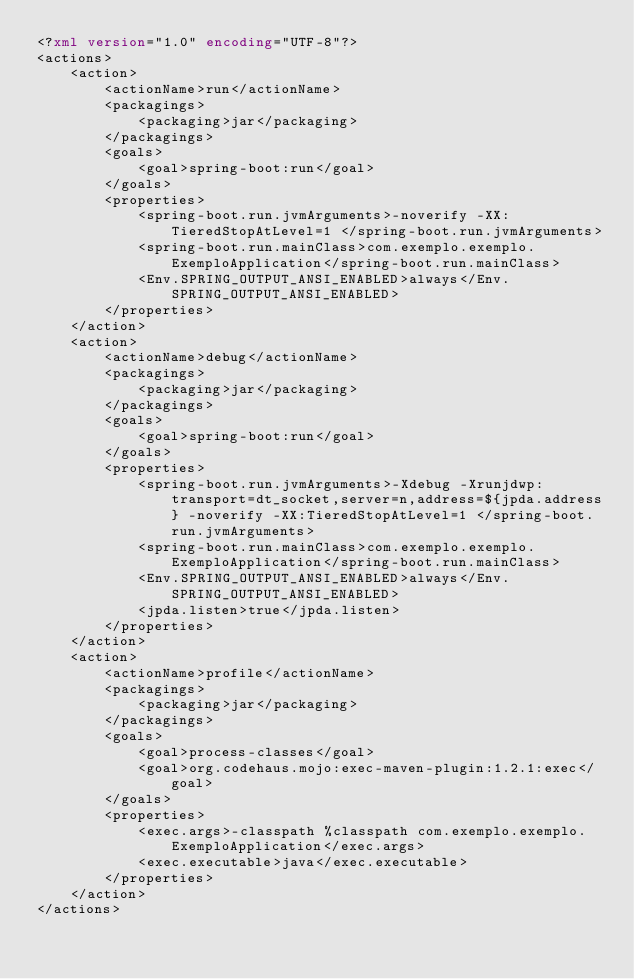Convert code to text. <code><loc_0><loc_0><loc_500><loc_500><_XML_><?xml version="1.0" encoding="UTF-8"?>
<actions>
    <action>
        <actionName>run</actionName>
        <packagings>
            <packaging>jar</packaging>
        </packagings>
        <goals>
            <goal>spring-boot:run</goal>
        </goals>
        <properties>
            <spring-boot.run.jvmArguments>-noverify -XX:TieredStopAtLevel=1 </spring-boot.run.jvmArguments>
            <spring-boot.run.mainClass>com.exemplo.exemplo.ExemploApplication</spring-boot.run.mainClass>
            <Env.SPRING_OUTPUT_ANSI_ENABLED>always</Env.SPRING_OUTPUT_ANSI_ENABLED>
        </properties>
    </action>
    <action>
        <actionName>debug</actionName>
        <packagings>
            <packaging>jar</packaging>
        </packagings>
        <goals>
            <goal>spring-boot:run</goal>
        </goals>
        <properties>
            <spring-boot.run.jvmArguments>-Xdebug -Xrunjdwp:transport=dt_socket,server=n,address=${jpda.address} -noverify -XX:TieredStopAtLevel=1 </spring-boot.run.jvmArguments>
            <spring-boot.run.mainClass>com.exemplo.exemplo.ExemploApplication</spring-boot.run.mainClass>
            <Env.SPRING_OUTPUT_ANSI_ENABLED>always</Env.SPRING_OUTPUT_ANSI_ENABLED>
            <jpda.listen>true</jpda.listen>
        </properties>
    </action>
    <action>
        <actionName>profile</actionName>
        <packagings>
            <packaging>jar</packaging>
        </packagings>
        <goals>
            <goal>process-classes</goal>
            <goal>org.codehaus.mojo:exec-maven-plugin:1.2.1:exec</goal>
        </goals>
        <properties>
            <exec.args>-classpath %classpath com.exemplo.exemplo.ExemploApplication</exec.args>
            <exec.executable>java</exec.executable>
        </properties>
    </action>
</actions>
</code> 